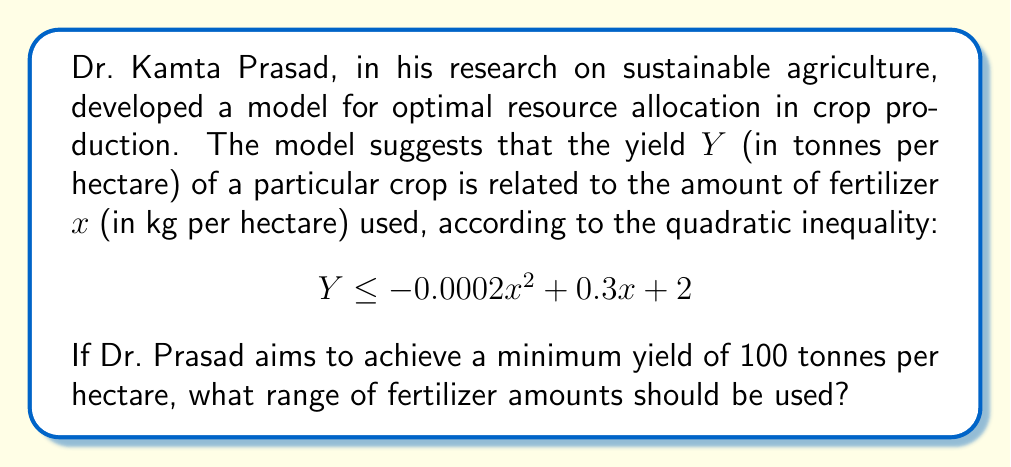Show me your answer to this math problem. To solve this problem, we need to follow these steps:

1) The inequality for the minimum yield of 100 tonnes per hectare is:

   $$100 \leq -0.0002x^2 + 0.3x + 2$$

2) Rearrange the inequality:

   $$0 \leq -0.0002x^2 + 0.3x - 98$$

3) This is a quadratic inequality. To solve it, we first need to find the roots of the quadratic equation:

   $$-0.0002x^2 + 0.3x - 98 = 0$$

4) We can solve this using the quadratic formula: $x = \frac{-b \pm \sqrt{b^2 - 4ac}}{2a}$

   Where $a = -0.0002$, $b = 0.3$, and $c = -98$

5) Substituting these values:

   $$x = \frac{-0.3 \pm \sqrt{0.3^2 - 4(-0.0002)(-98)}}{2(-0.0002)}$$

6) Simplifying:

   $$x = \frac{-0.3 \pm \sqrt{0.09 + 0.0784}}{-0.0004} = \frac{-0.3 \pm \sqrt{0.1684}}{-0.0004} = \frac{-0.3 \pm 0.4103}{-0.0004}$$

7) This gives us two solutions:

   $x_1 = \frac{-0.3 + 0.4103}{-0.0004} \approx 276.75$
   $x_2 = \frac{-0.3 - 0.4103}{-0.0004} \approx 1775.75$

8) The inequality is satisfied when $x$ is between these two values. Therefore, the range of fertilizer amounts is:

   $$276.75 \leq x \leq 1775.75$$
Answer: $276.75 \leq x \leq 1775.75$ kg/hectare 